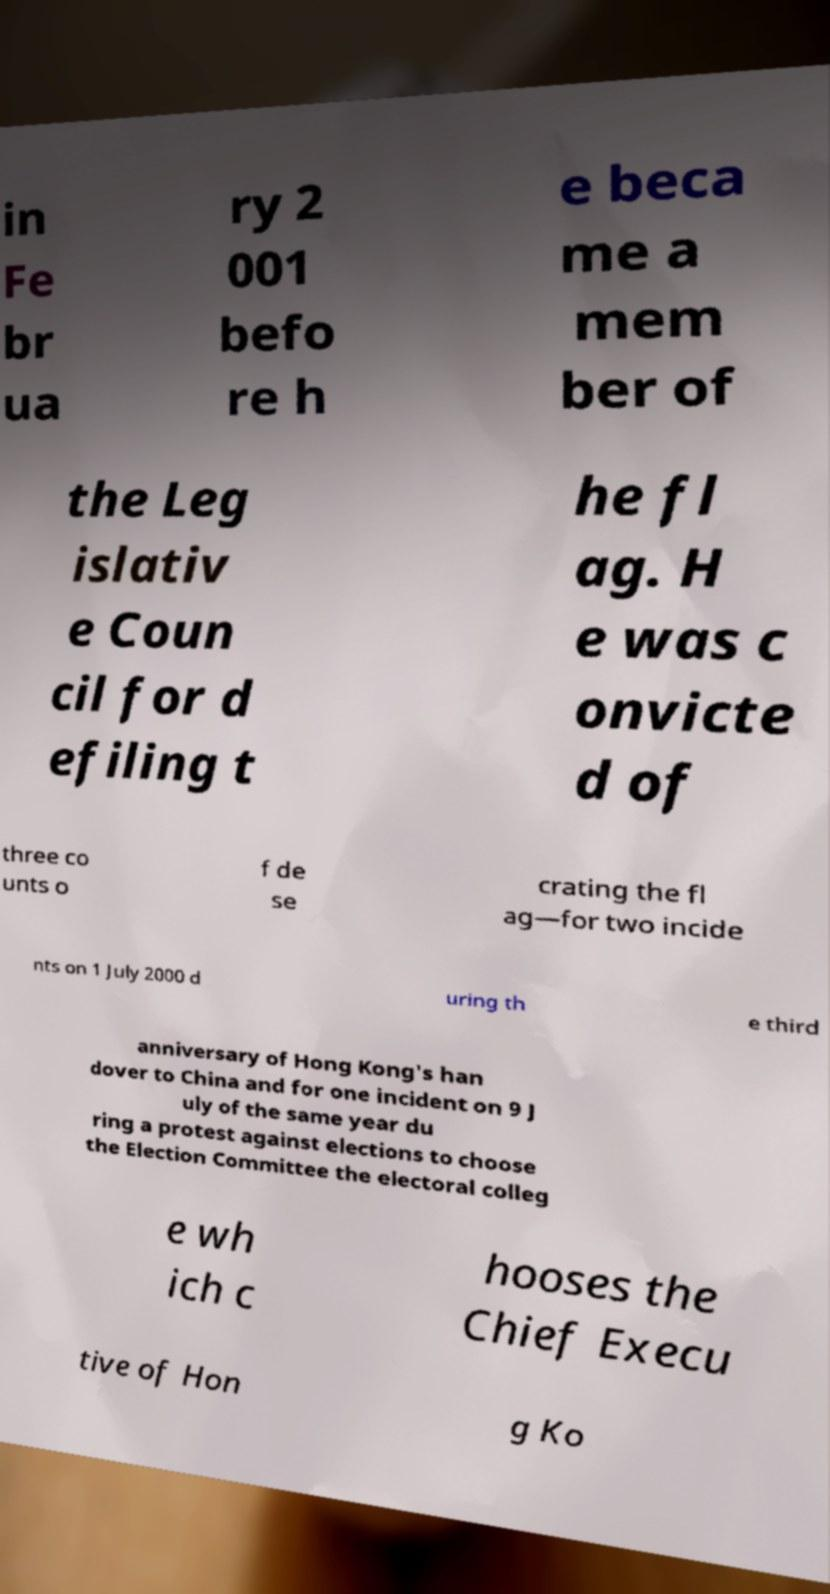I need the written content from this picture converted into text. Can you do that? in Fe br ua ry 2 001 befo re h e beca me a mem ber of the Leg islativ e Coun cil for d efiling t he fl ag. H e was c onvicte d of three co unts o f de se crating the fl ag—for two incide nts on 1 July 2000 d uring th e third anniversary of Hong Kong's han dover to China and for one incident on 9 J uly of the same year du ring a protest against elections to choose the Election Committee the electoral colleg e wh ich c hooses the Chief Execu tive of Hon g Ko 